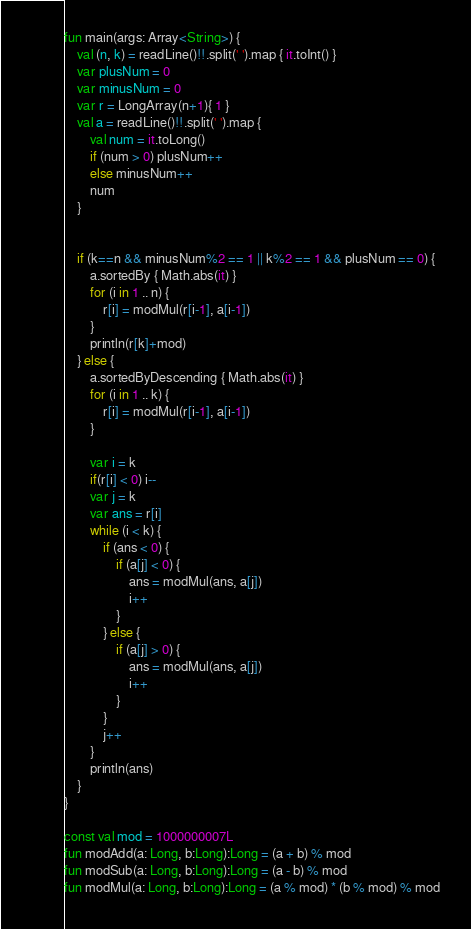Convert code to text. <code><loc_0><loc_0><loc_500><loc_500><_Kotlin_>fun main(args: Array<String>) {
    val (n, k) = readLine()!!.split(' ').map { it.toInt() }
    var plusNum = 0
    var minusNum = 0
    var r = LongArray(n+1){ 1 }
    val a = readLine()!!.split(' ').map {
        val num = it.toLong()
        if (num > 0) plusNum++
        else minusNum++
        num
    }


    if (k==n && minusNum%2 == 1 || k%2 == 1 && plusNum == 0) {
        a.sortedBy { Math.abs(it) }
        for (i in 1 .. n) {
            r[i] = modMul(r[i-1], a[i-1])
        }
        println(r[k]+mod)
    } else {
        a.sortedByDescending { Math.abs(it) }
        for (i in 1 .. k) {
            r[i] = modMul(r[i-1], a[i-1])
        }

        var i = k
        if(r[i] < 0) i--
        var j = k
        var ans = r[i]
        while (i < k) {
            if (ans < 0) {
                if (a[j] < 0) {
                    ans = modMul(ans, a[j])
                    i++
                }
            } else {
                if (a[j] > 0) {
                    ans = modMul(ans, a[j])
                    i++
                }
            }
            j++
        }
        println(ans)
    }
}

const val mod = 1000000007L
fun modAdd(a: Long, b:Long):Long = (a + b) % mod
fun modSub(a: Long, b:Long):Long = (a - b) % mod
fun modMul(a: Long, b:Long):Long = (a % mod) * (b % mod) % mod
</code> 